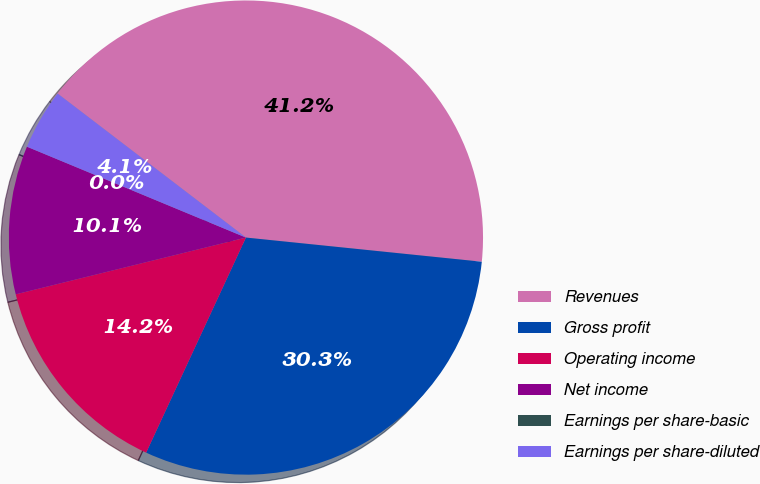Convert chart to OTSL. <chart><loc_0><loc_0><loc_500><loc_500><pie_chart><fcel>Revenues<fcel>Gross profit<fcel>Operating income<fcel>Net income<fcel>Earnings per share-basic<fcel>Earnings per share-diluted<nl><fcel>41.24%<fcel>30.29%<fcel>14.24%<fcel>10.11%<fcel>0.0%<fcel>4.13%<nl></chart> 